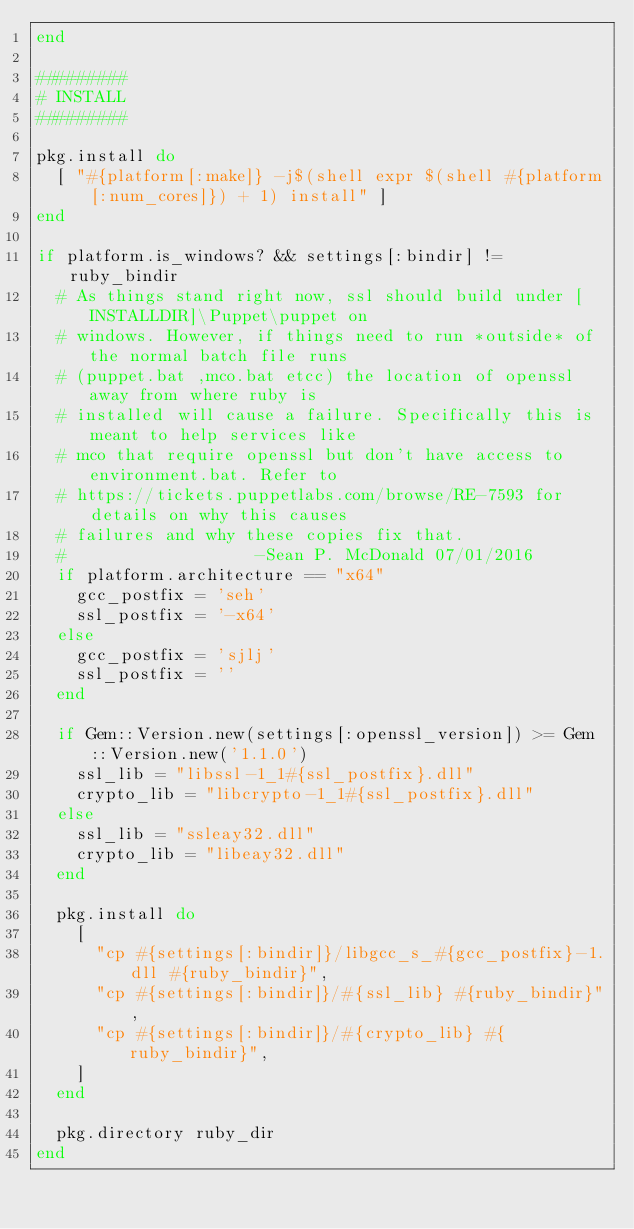Convert code to text. <code><loc_0><loc_0><loc_500><loc_500><_Ruby_>end

#########
# INSTALL
#########

pkg.install do
  [ "#{platform[:make]} -j$(shell expr $(shell #{platform[:num_cores]}) + 1) install" ]
end

if platform.is_windows? && settings[:bindir] != ruby_bindir
  # As things stand right now, ssl should build under [INSTALLDIR]\Puppet\puppet on
  # windows. However, if things need to run *outside* of the normal batch file runs
  # (puppet.bat ,mco.bat etcc) the location of openssl away from where ruby is
  # installed will cause a failure. Specifically this is meant to help services like
  # mco that require openssl but don't have access to environment.bat. Refer to
  # https://tickets.puppetlabs.com/browse/RE-7593 for details on why this causes
  # failures and why these copies fix that.
  #                   -Sean P. McDonald 07/01/2016
  if platform.architecture == "x64"
    gcc_postfix = 'seh'
    ssl_postfix = '-x64'
  else
    gcc_postfix = 'sjlj'
    ssl_postfix = ''
  end

  if Gem::Version.new(settings[:openssl_version]) >= Gem::Version.new('1.1.0')
    ssl_lib = "libssl-1_1#{ssl_postfix}.dll"
    crypto_lib = "libcrypto-1_1#{ssl_postfix}.dll"
  else
    ssl_lib = "ssleay32.dll"
    crypto_lib = "libeay32.dll"
  end

  pkg.install do
    [
      "cp #{settings[:bindir]}/libgcc_s_#{gcc_postfix}-1.dll #{ruby_bindir}",
      "cp #{settings[:bindir]}/#{ssl_lib} #{ruby_bindir}",
      "cp #{settings[:bindir]}/#{crypto_lib} #{ruby_bindir}",
    ]
  end

  pkg.directory ruby_dir
end
</code> 